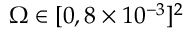Convert formula to latex. <formula><loc_0><loc_0><loc_500><loc_500>\Omega \in [ 0 , 8 \times 1 0 ^ { - 3 } ] ^ { 2 }</formula> 